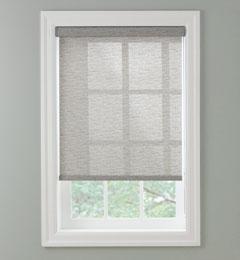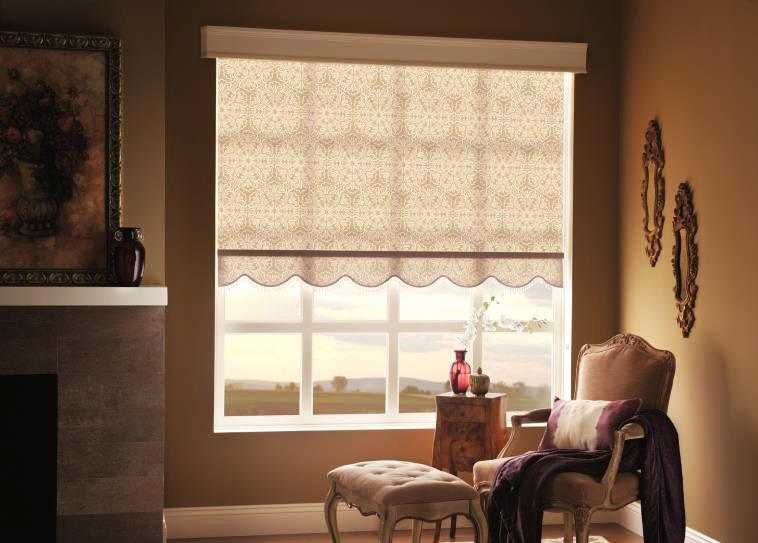The first image is the image on the left, the second image is the image on the right. Assess this claim about the two images: "There is one solid blue chair/couch visible.". Correct or not? Answer yes or no. No. The first image is the image on the left, the second image is the image on the right. Analyze the images presented: Is the assertion "The left image shows one shade with a straight bottom hanging in front of, but not fully covering, a white paned window." valid? Answer yes or no. Yes. 